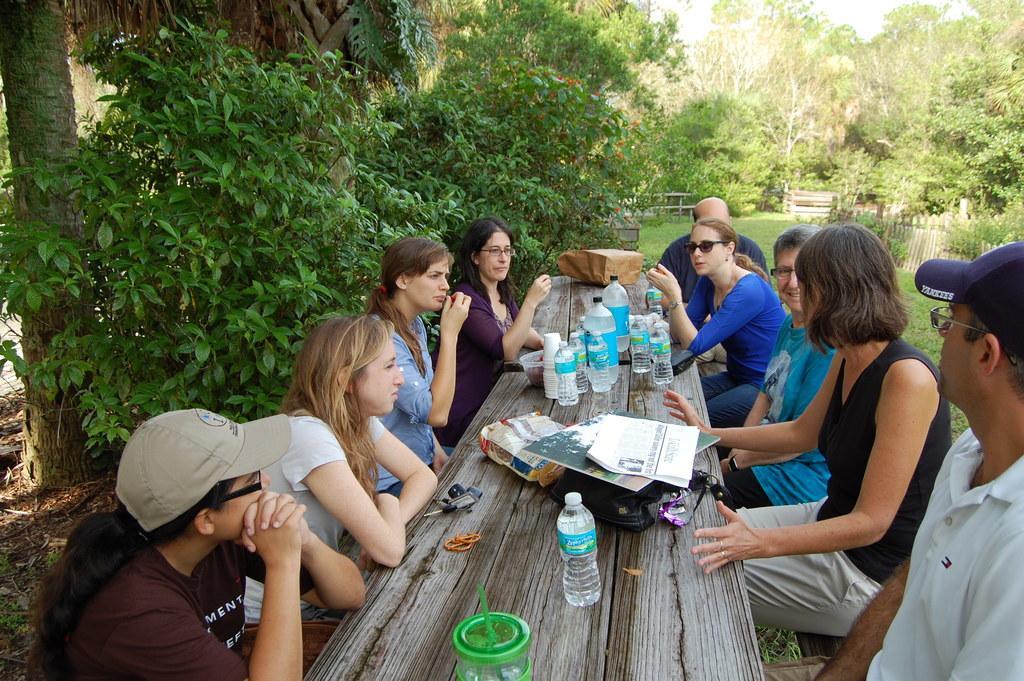How would you summarize this image in a sentence or two? This picture shows a group of people seated on the bench and we see few water bottles papers on the bench and we see few trees around 